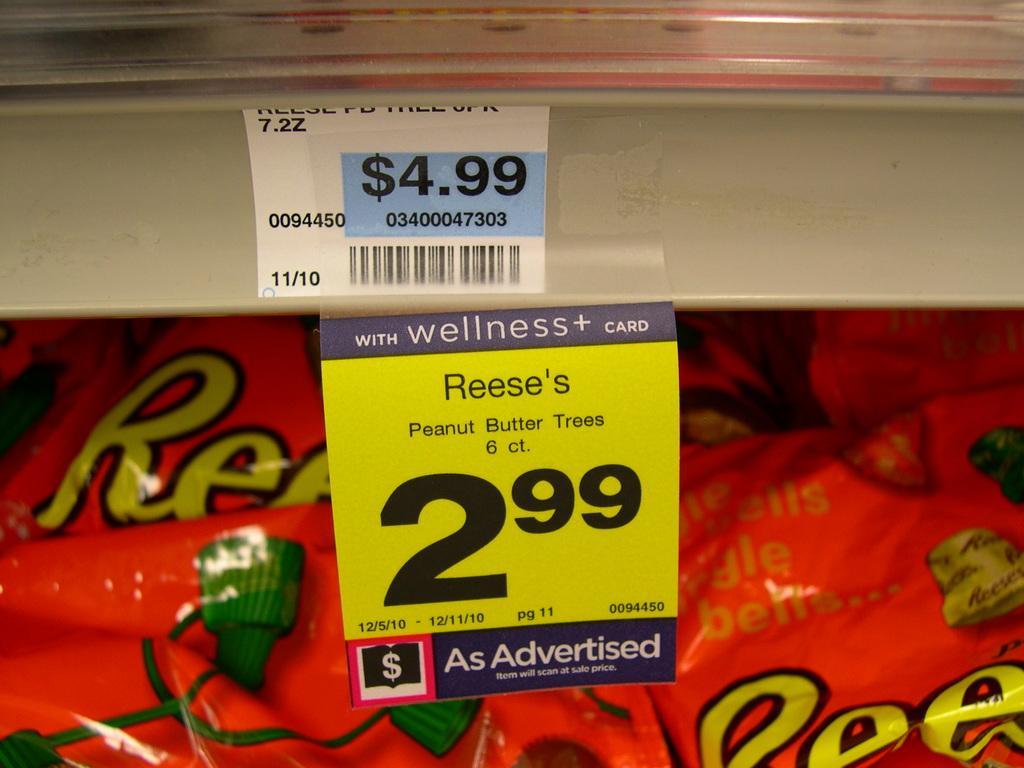Please provide a concise description of this image. In this picture we can see price rates and in the background we can see a red color banner. 